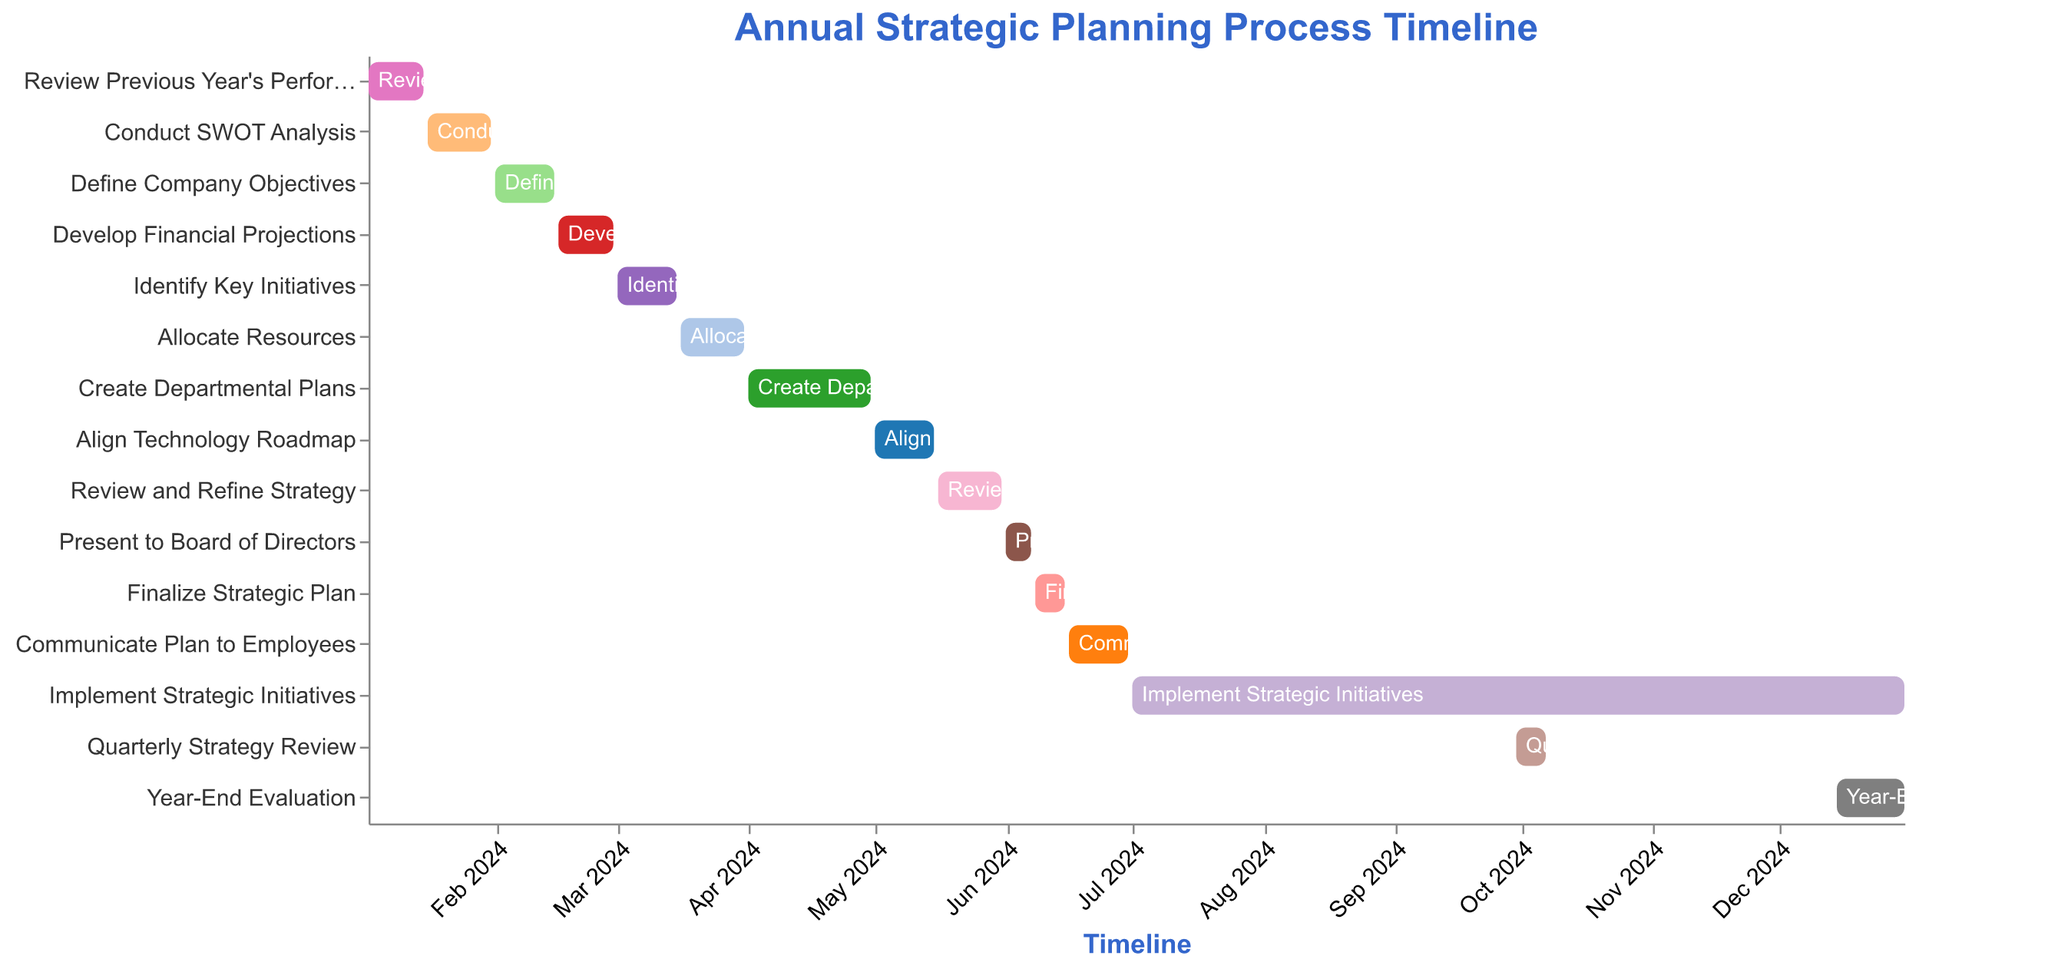What is the title of the Gantt Chart? The title is displayed at the top of the chart and is descriptive of the data being visualized. It reads "Annual Strategic Planning Process Timeline".
Answer: Annual Strategic Planning Process Timeline Which task has the shortest duration in the Gantt Chart? By visually comparing the length of the bars representing each task, it is evident that "Present to Board of Directors" has the shortest bar, indicating the shortest duration.
Answer: Present to Board of Directors When does the task "Create Departmental Plans" start and end? The task "Create Departmental Plans" starts on 2024-04-01 and ends on 2024-04-30 according to its bar position and the corresponding dates on the timeline axis.
Answer: 2024-04-01 to 2024-04-30 Which two tasks overlap in March 2024? By examining the bars falling under March 2024 on the timeline axis, "Identify Key Initiatives" (2024-03-01 to 2024-03-15) and "Allocate Resources" (2024-03-16 to 2024-03-31) are found to overlap.
Answer: Identify Key Initiatives and Allocate Resources What is the duration of the "Implement Strategic Initiatives" task? The task "Implement Strategic Initiatives" starts on 2024-07-01 and ends on 2024-12-31. The duration can be calculated by counting the months between these two dates, which is 6 months.
Answer: 6 months How many tasks are there in total within the timeline? Counting all the unique bars or tasks from top to bottom provides a total of 15 tasks listed.
Answer: 15 tasks Which task immediately follows "Align Technology Roadmap"? By observing the sequence of the tasks, "Review and Refine Strategy" immediately follows "Align Technology Roadmap" within the chart.
Answer: Review and Refine Strategy Which month has the highest number of tasks starting? By examining the start dates of the tasks, March 2024 has three tasks starting: Identify Key Initiatives, Allocate Resources, and Create Departmental Plans.
Answer: March 2024 What tasks are completed by the end of April 2024? By checking the end dates against April 2024, tasks completed by the end of April include "Review Previous Year's Performance", "Conduct SWOT Analysis", "Define Company Objectives", "Develop Financial Projections", "Identify Key Initiatives", and "Allocate Resources".
Answer: Review Previous Year's Performance, Conduct SWOT Analysis, Define Company Objectives, Develop Financial Projections, Identify Key Initiatives, Allocate Resources When is the "Quarterly Strategy Review" conducted, and how long does it last? "Quarterly Strategy Review" is conducted from 2024-09-30 to 2024-10-07, lasting 8 days when you count the days between the start and end dates.
Answer: 2024-09-30 to 2024-10-07, 8 days 